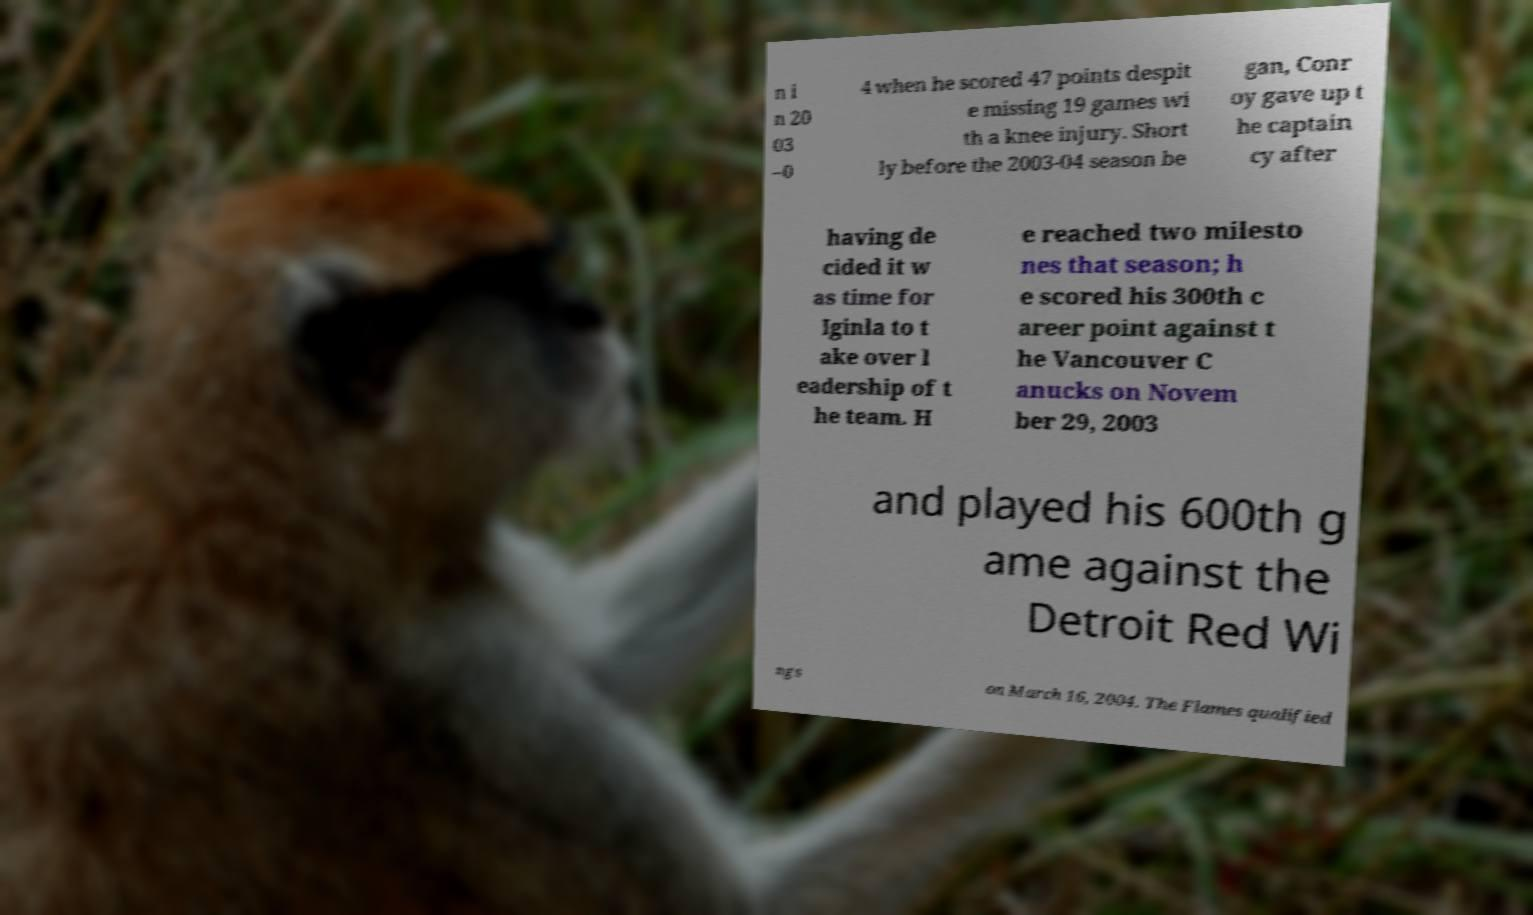There's text embedded in this image that I need extracted. Can you transcribe it verbatim? n i n 20 03 –0 4 when he scored 47 points despit e missing 19 games wi th a knee injury. Short ly before the 2003-04 season be gan, Conr oy gave up t he captain cy after having de cided it w as time for Iginla to t ake over l eadership of t he team. H e reached two milesto nes that season; h e scored his 300th c areer point against t he Vancouver C anucks on Novem ber 29, 2003 and played his 600th g ame against the Detroit Red Wi ngs on March 16, 2004. The Flames qualified 